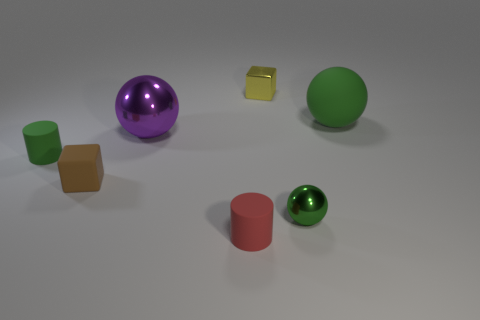What color is the large sphere that is made of the same material as the brown object?
Provide a short and direct response. Green. What is the size of the cube that is in front of the thing on the left side of the small block in front of the big purple thing?
Your response must be concise. Small. Are there fewer large red metal cylinders than yellow things?
Ensure brevity in your answer.  Yes. What is the color of the other shiny thing that is the same shape as the large shiny thing?
Offer a terse response. Green. There is a green thing to the left of the metal sphere to the left of the yellow metal object; is there a small cylinder that is behind it?
Provide a succinct answer. No. Do the brown matte object and the red thing have the same shape?
Provide a short and direct response. No. Are there fewer green things in front of the small red rubber thing than purple balls?
Give a very brief answer. Yes. There is a small shiny object that is in front of the block behind the green ball behind the brown rubber object; what color is it?
Offer a terse response. Green. How many metal objects are gray blocks or small objects?
Your response must be concise. 2. Does the purple ball have the same size as the yellow thing?
Keep it short and to the point. No. 